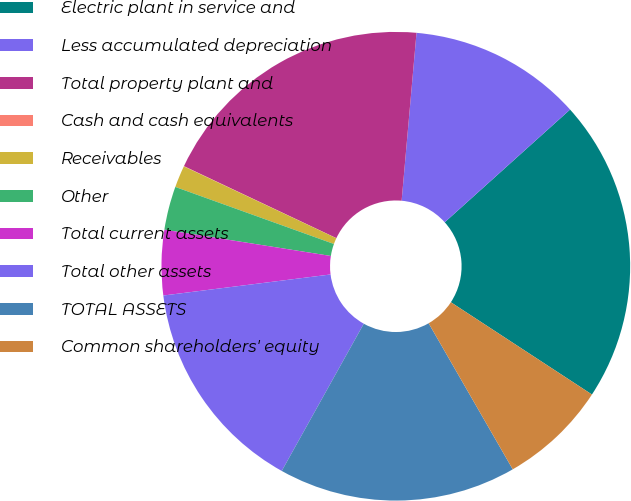<chart> <loc_0><loc_0><loc_500><loc_500><pie_chart><fcel>Electric plant in service and<fcel>Less accumulated depreciation<fcel>Total property plant and<fcel>Cash and cash equivalents<fcel>Receivables<fcel>Other<fcel>Total current assets<fcel>Total other assets<fcel>TOTAL ASSETS<fcel>Common shareholders' equity<nl><fcel>20.88%<fcel>11.94%<fcel>19.39%<fcel>0.02%<fcel>1.51%<fcel>3.0%<fcel>4.49%<fcel>14.92%<fcel>16.41%<fcel>7.47%<nl></chart> 